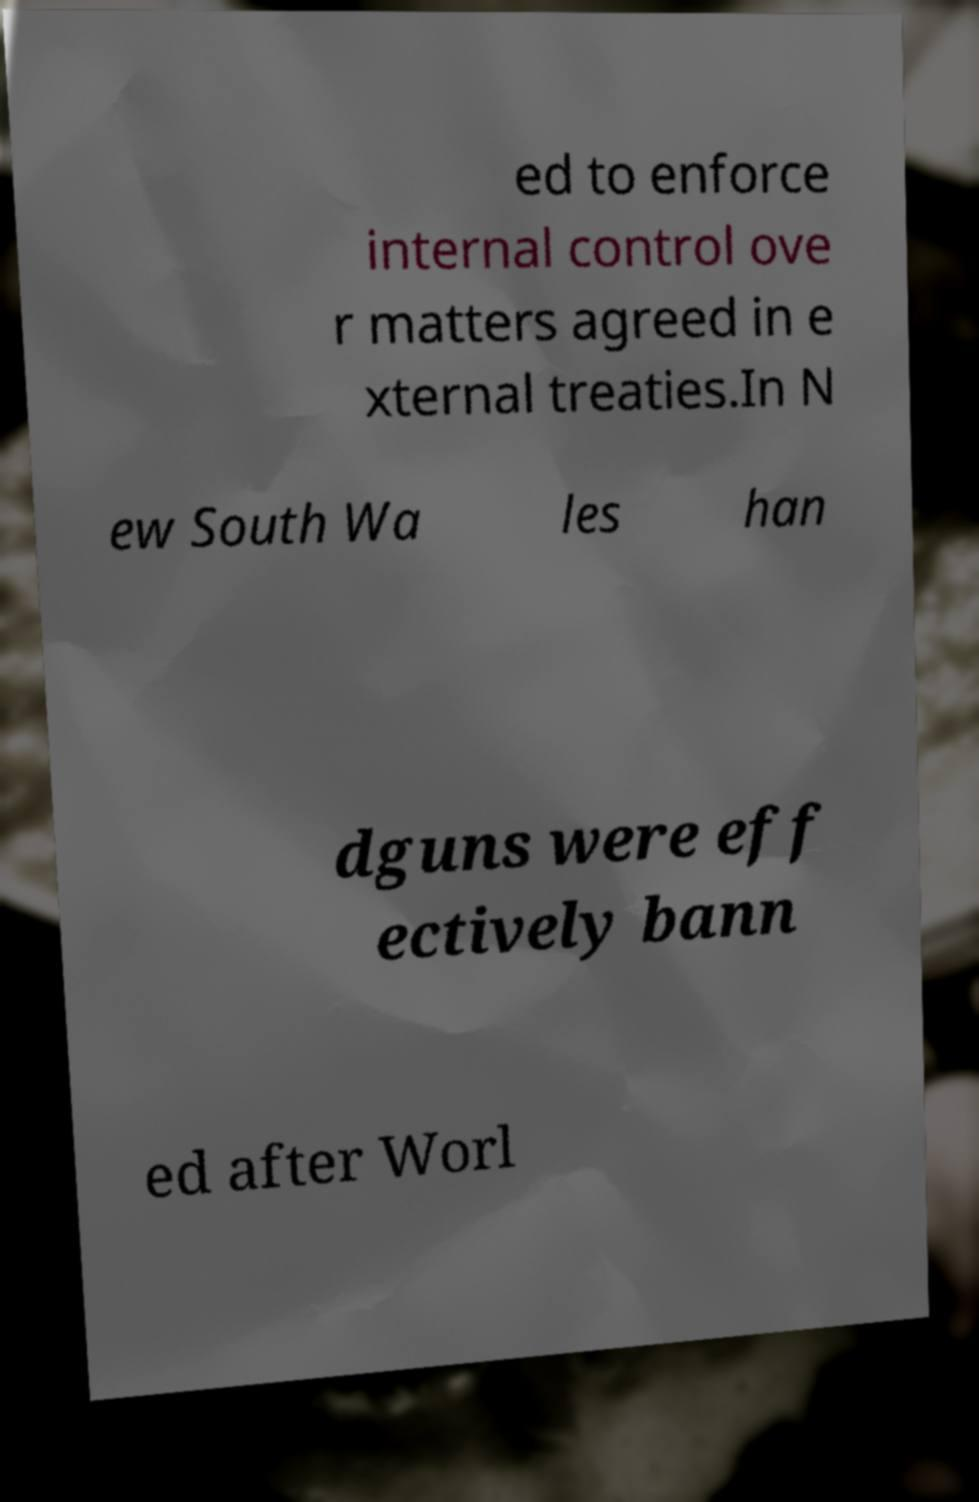Please read and relay the text visible in this image. What does it say? ed to enforce internal control ove r matters agreed in e xternal treaties.In N ew South Wa les han dguns were eff ectively bann ed after Worl 